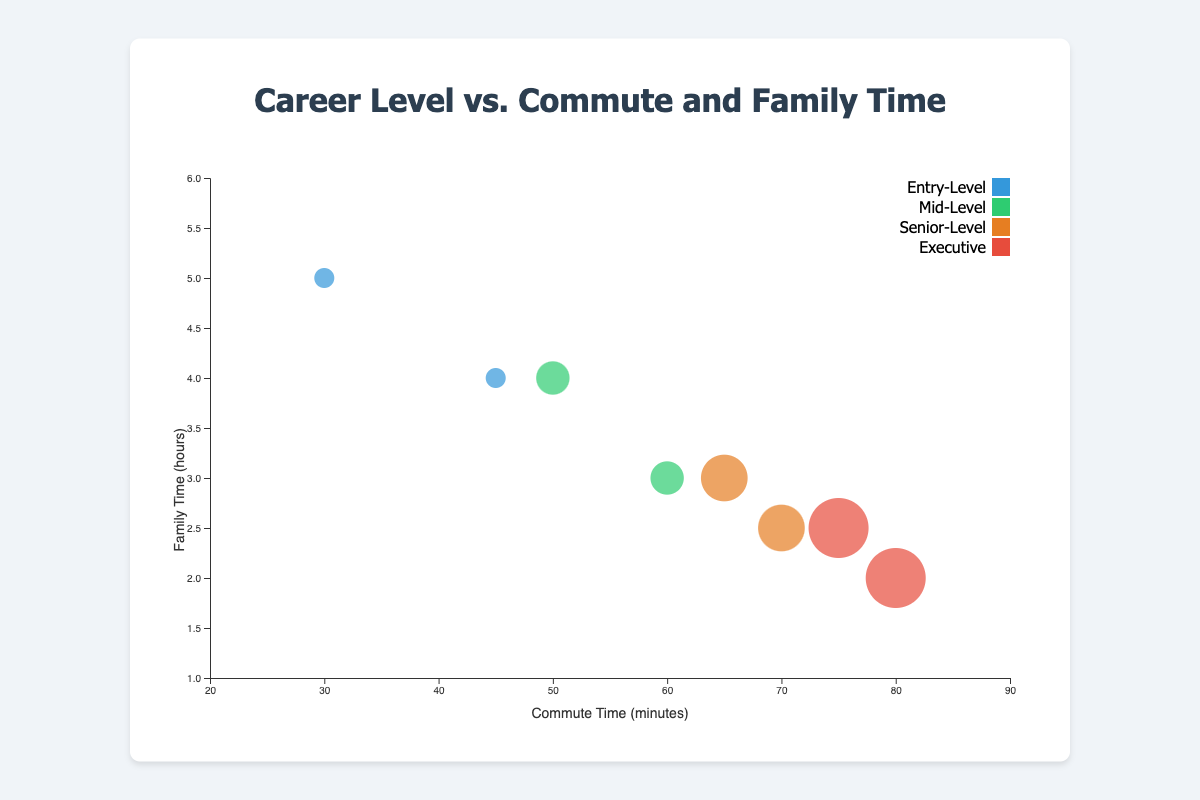How many bubbles represent the Entry-Level career? There are two Entry-Level career data points indicated by their commute times (30 and 45 minutes) and family times (5 and 4 hours, respectively).
Answer: 2 Which Career Level has the highest commute time? The Executive career level has the highest commute times, which are 80 and 75 minutes.
Answer: Executive What is the range of family time hours in the Mid-Level career? Mid-Level careers have family time data points of 3 and 4 hours. The range is calculated as the difference between the maximum and minimum values: 4 - 3 = 1 hour.
Answer: 1 hour How does family time generally change as career level increases? Family time generally decreases as career level increases, as higher-level careers (Senior-Level and Executive) exhibit lower family times compared to Entry-Level and Mid-Level careers.
Answer: Decreases Are there any bubbles with the same commute time but different family times? No, each data point in the chart has a unique combination of commute time and family time.
Answer: No What is the size of the bubble representing the Senior Marketing Director? The Senior Marketing Director is represented by the Senior-Level career bubble size of 3.
Answer: 3 Which two career levels have overlapping family time but different commute times? Senior-Level (2.5 and 3 hours) and Executive (2.5 hours) share overlapping family times with different commute times of 70, 65, and 75 minutes, respectively.
Answer: Senior-Level, Executive Calculate the average commute time for Entry-Level careers. The commute times for Entry-Level careers are 30 and 45 minutes. The average is calculated as (30 + 45) / 2 = 37.5 minutes.
Answer: 37.5 minutes Which Career Level has the most uniformly sized bubbles? Entry-Level has uniformly sized bubbles since both bubbles representing this level have a size of 1.
Answer: Entry-Level What is the relationship between bubble size and career level? Bubble size increases with career level, indicating higher positions correspond to larger bubble sizes. Entry-Level has the smallest bubble size (1), Mid-Level has size (2), Senior-Level has size (3), and Executive has the largest bubble size (4).
Answer: Higher career level, larger bubble size 